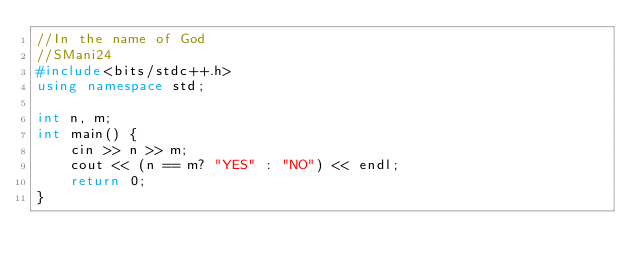Convert code to text. <code><loc_0><loc_0><loc_500><loc_500><_C++_>//In the name of God
//SMani24
#include<bits/stdc++.h>
using namespace std;

int n, m;
int main() {
	cin >> n >> m;
	cout << (n == m? "YES" : "NO") << endl;
	return 0;
}
</code> 